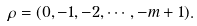<formula> <loc_0><loc_0><loc_500><loc_500>\rho = ( 0 , - 1 , - 2 , \cdots , - m + 1 ) .</formula> 